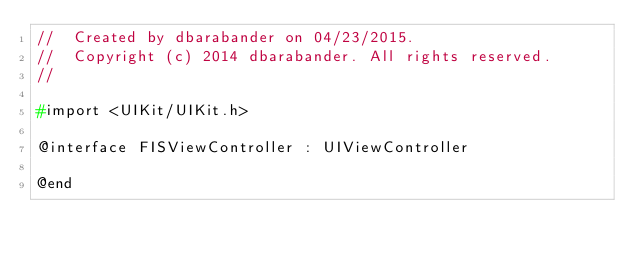<code> <loc_0><loc_0><loc_500><loc_500><_C_>//  Created by dbarabander on 04/23/2015.
//  Copyright (c) 2014 dbarabander. All rights reserved.
//

#import <UIKit/UIKit.h>

@interface FISViewController : UIViewController

@end
</code> 